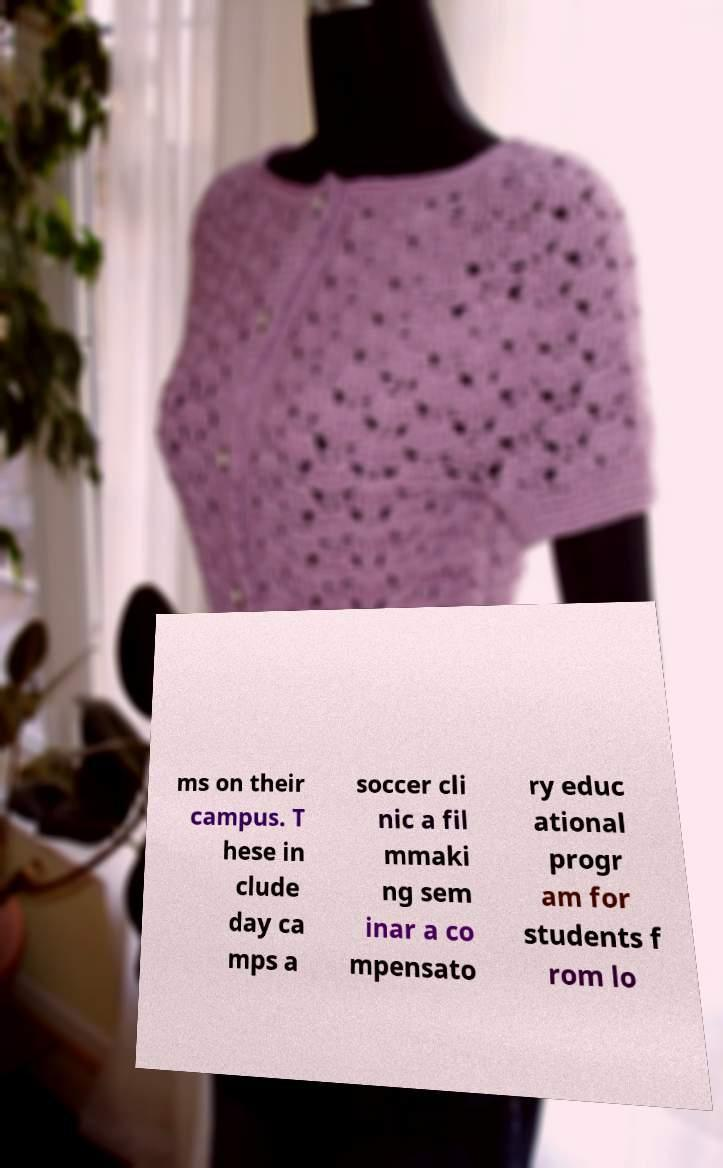Could you assist in decoding the text presented in this image and type it out clearly? ms on their campus. T hese in clude day ca mps a soccer cli nic a fil mmaki ng sem inar a co mpensato ry educ ational progr am for students f rom lo 